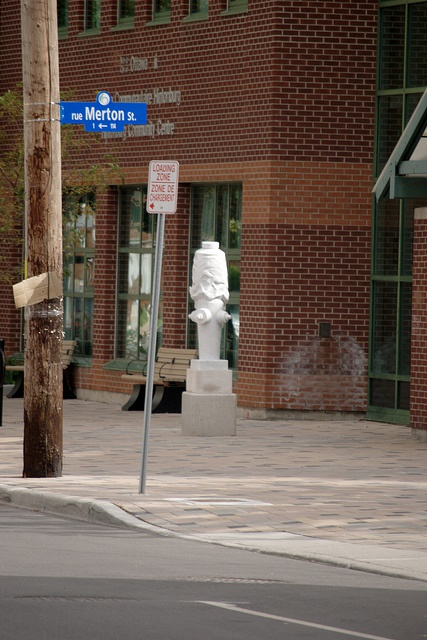Describe the objects in this image and their specific colors. I can see fire hydrant in black, lightgray, darkgray, and gray tones, bench in black and gray tones, and bench in black and gray tones in this image. 